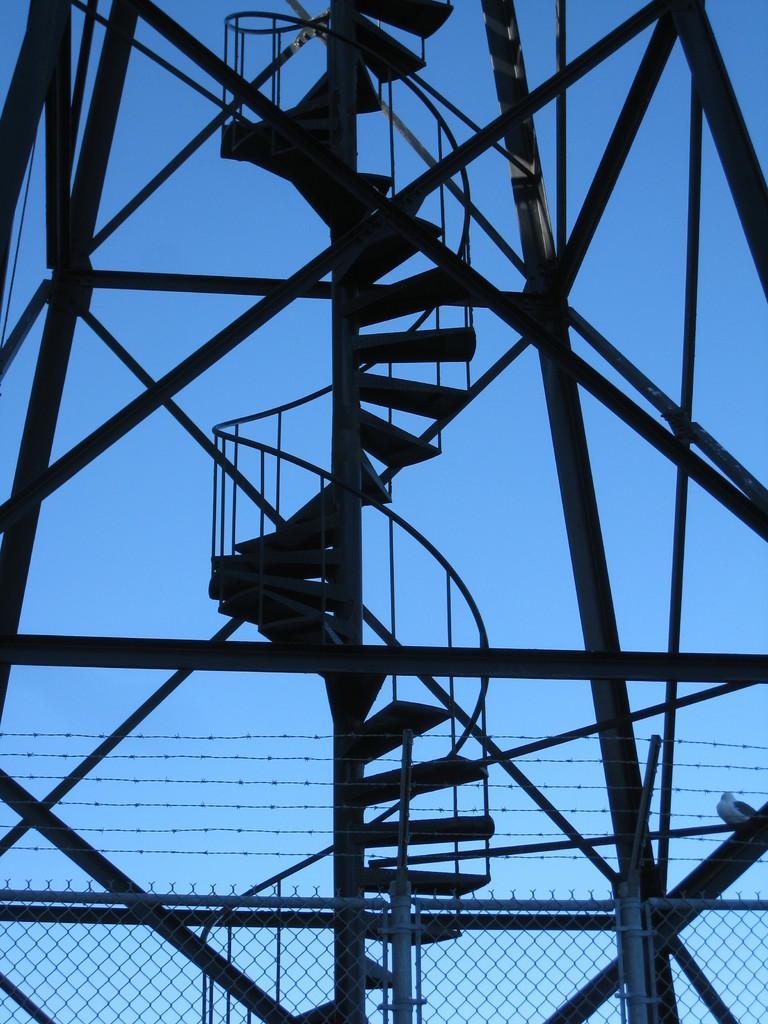How would you summarize this image in a sentence or two? In this image I can see a metal construction I can see stairs. I can see a fencing behind this construction and metal grills through which I can see the sky. 